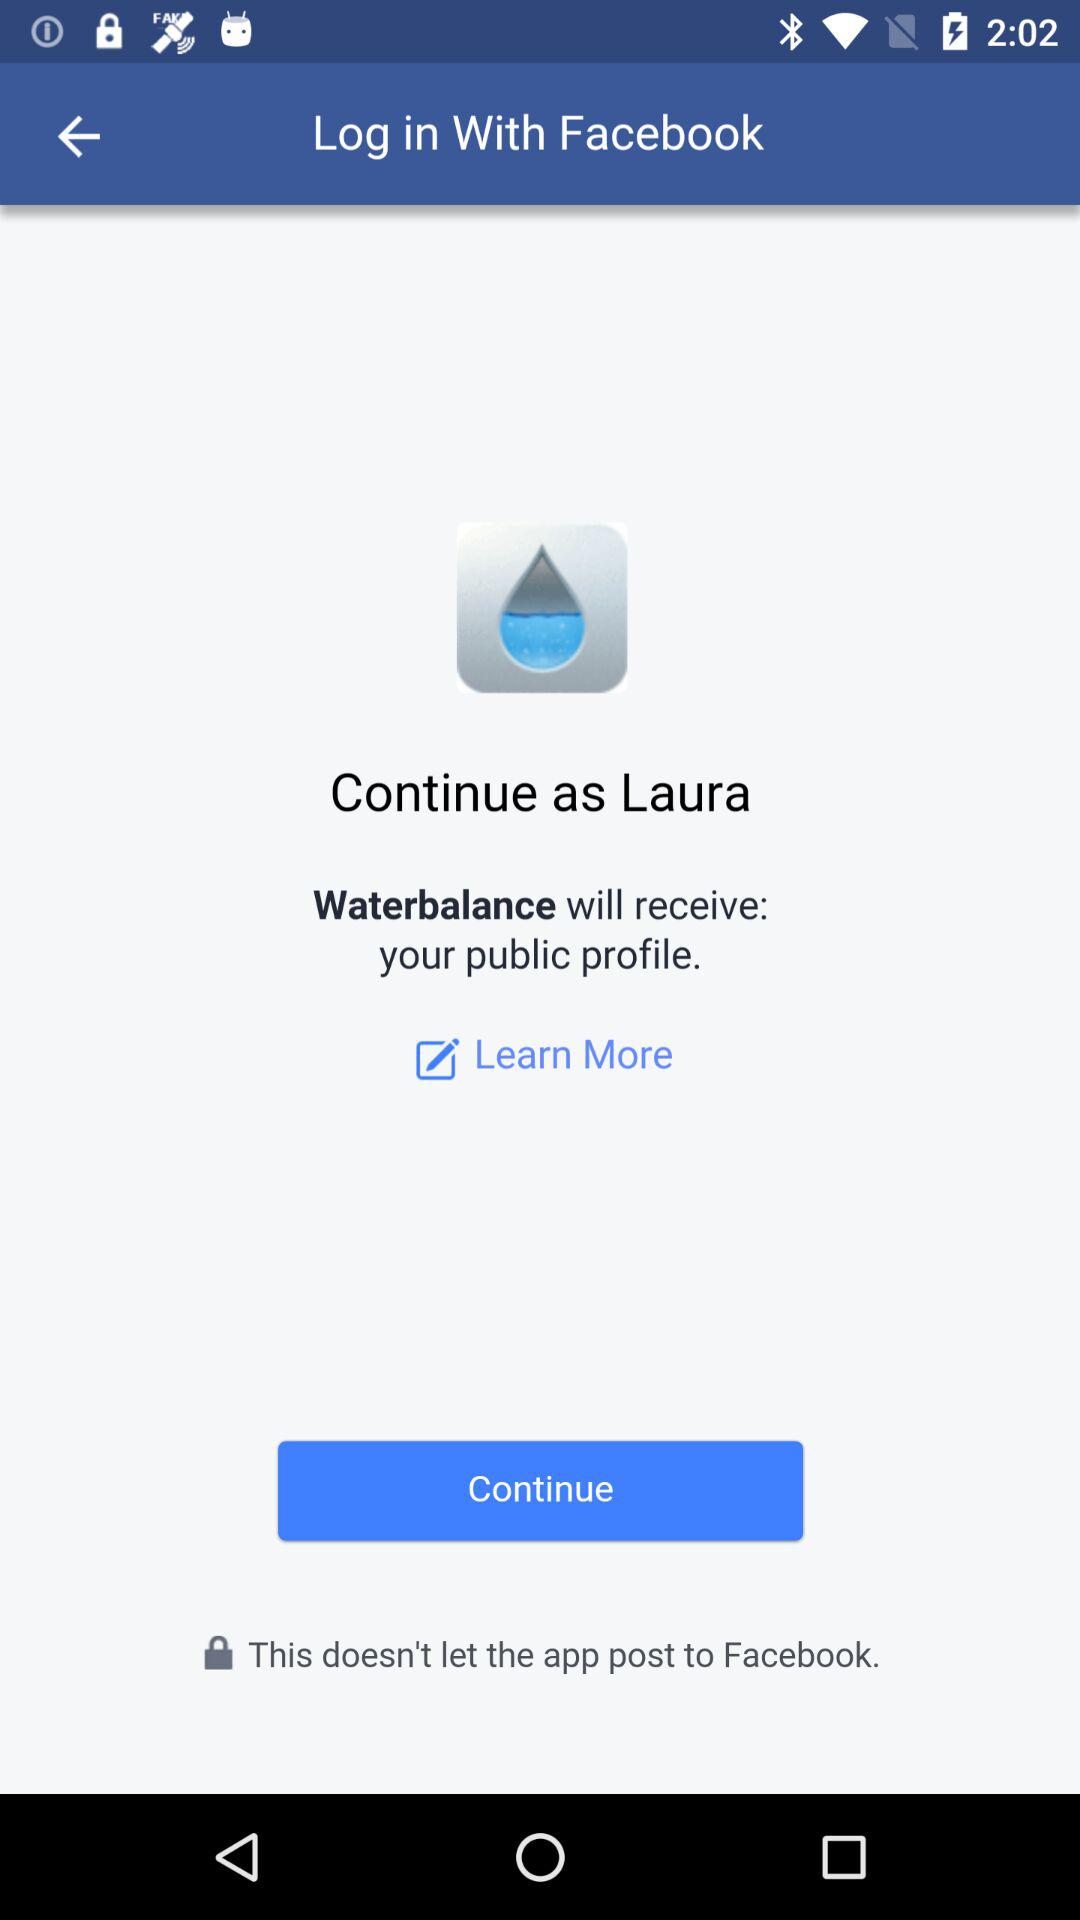What application is asking for permission? The application asking for permission is "Waterbalance". 